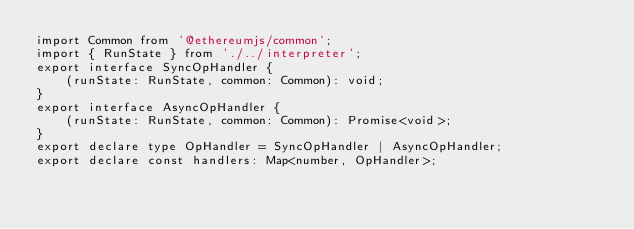<code> <loc_0><loc_0><loc_500><loc_500><_TypeScript_>import Common from '@ethereumjs/common';
import { RunState } from './../interpreter';
export interface SyncOpHandler {
    (runState: RunState, common: Common): void;
}
export interface AsyncOpHandler {
    (runState: RunState, common: Common): Promise<void>;
}
export declare type OpHandler = SyncOpHandler | AsyncOpHandler;
export declare const handlers: Map<number, OpHandler>;
</code> 